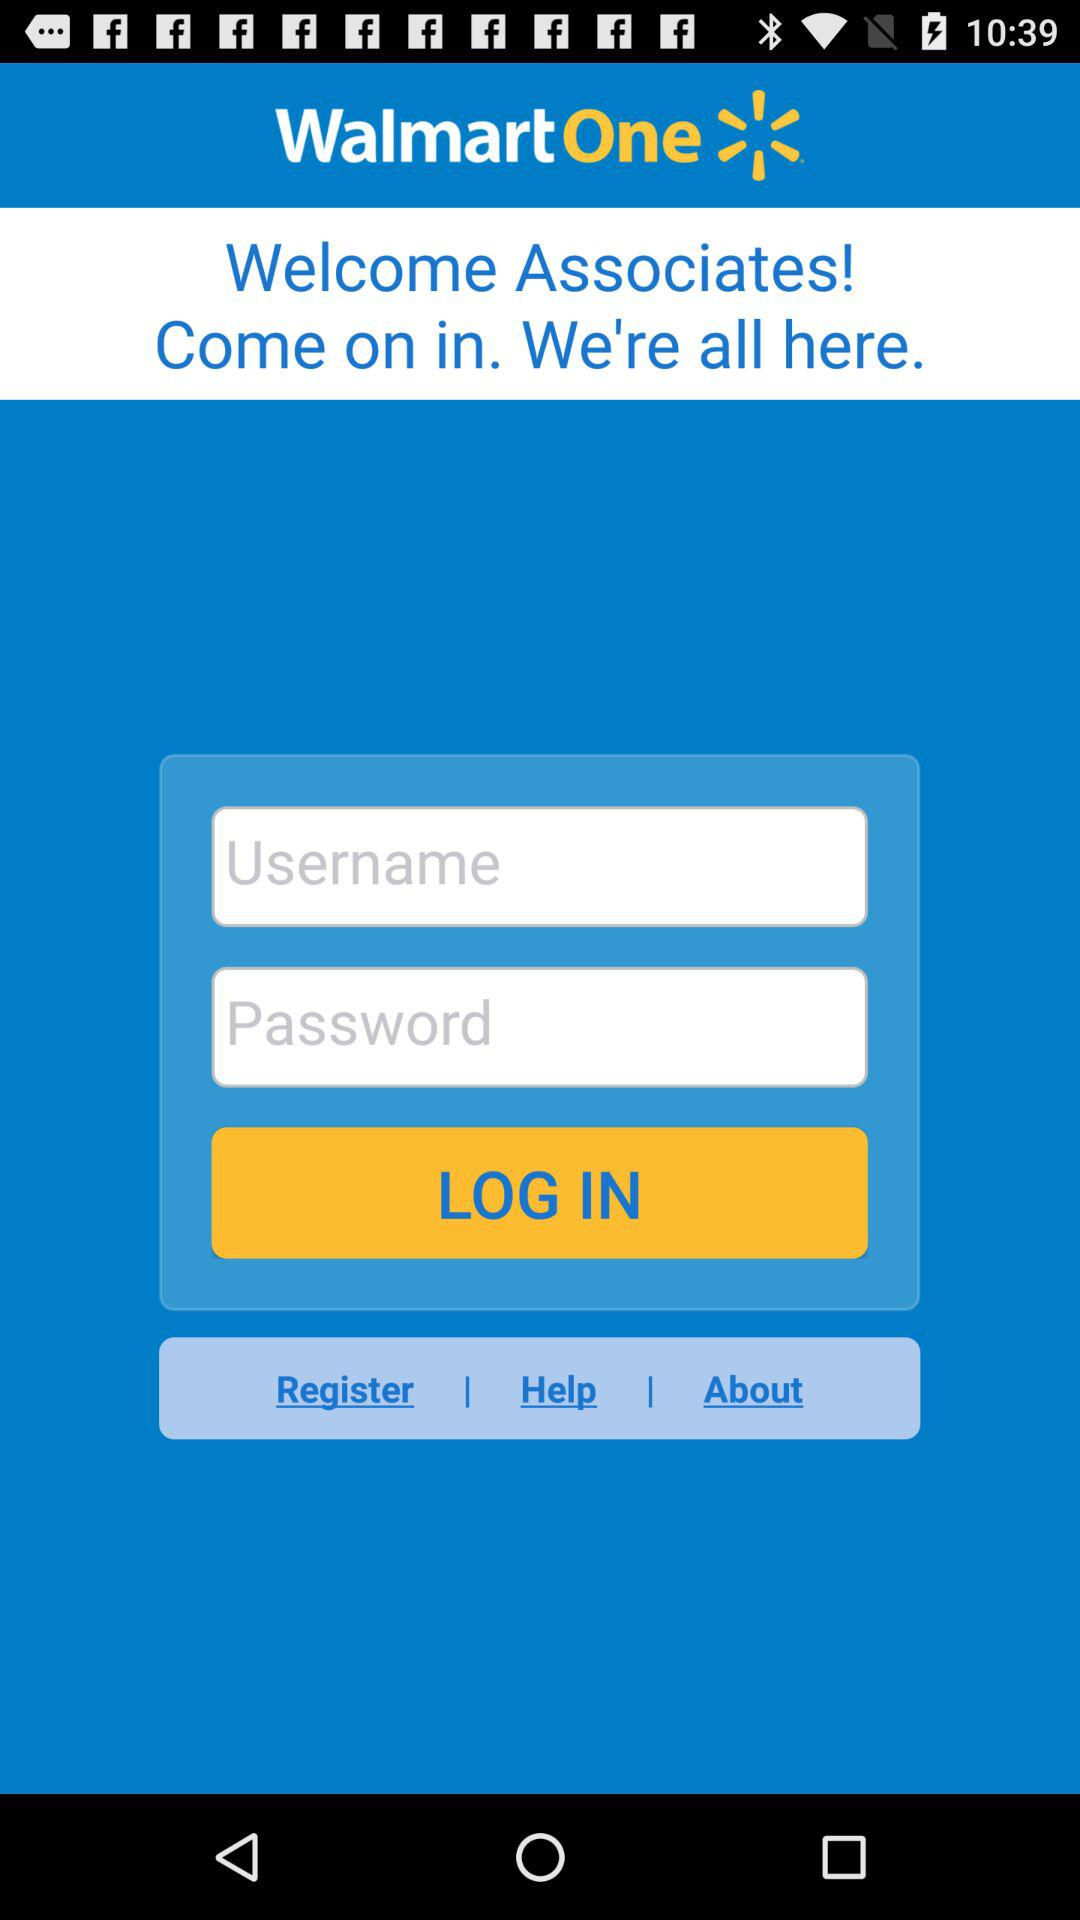What is the application name? The application name is "WalmartOne". 